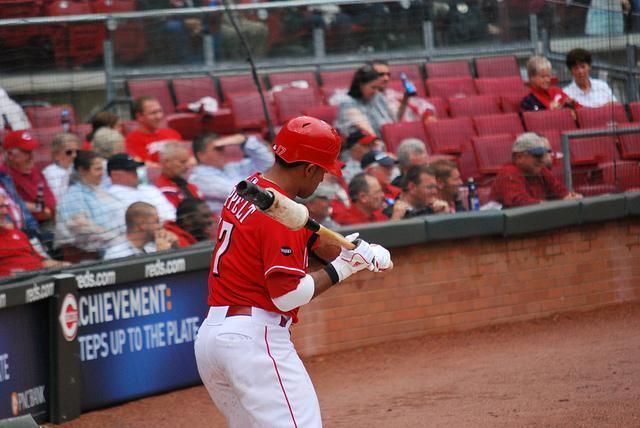How many people can be seen?
Give a very brief answer. 9. 